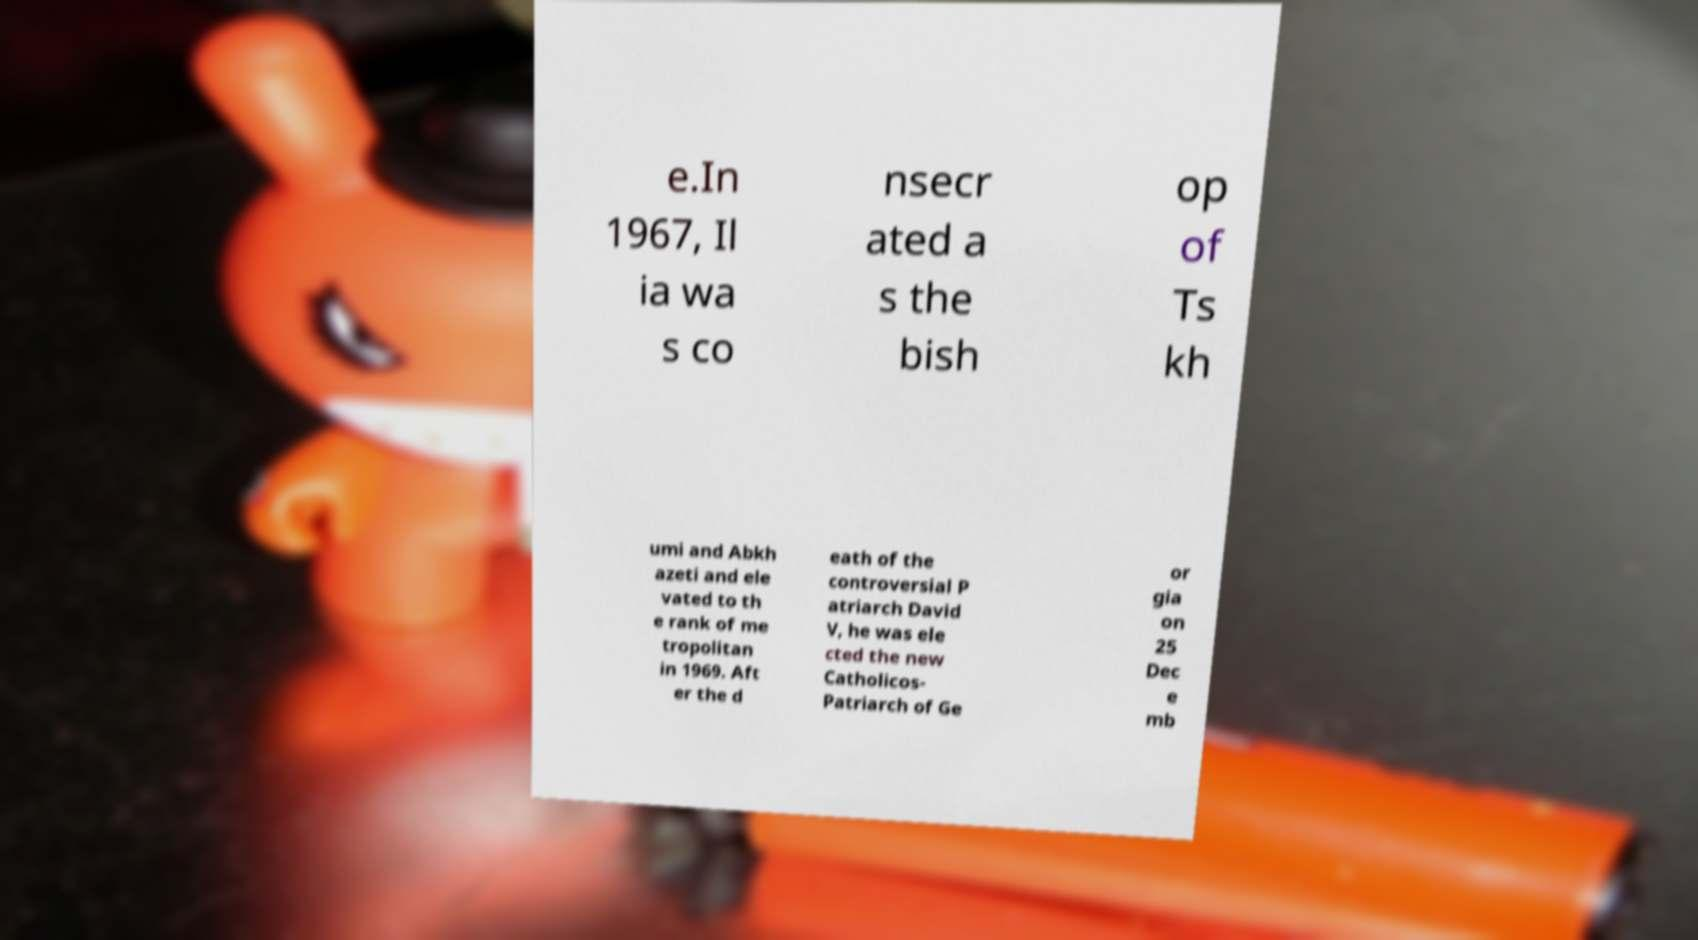There's text embedded in this image that I need extracted. Can you transcribe it verbatim? e.In 1967, Il ia wa s co nsecr ated a s the bish op of Ts kh umi and Abkh azeti and ele vated to th e rank of me tropolitan in 1969. Aft er the d eath of the controversial P atriarch David V, he was ele cted the new Catholicos- Patriarch of Ge or gia on 25 Dec e mb 